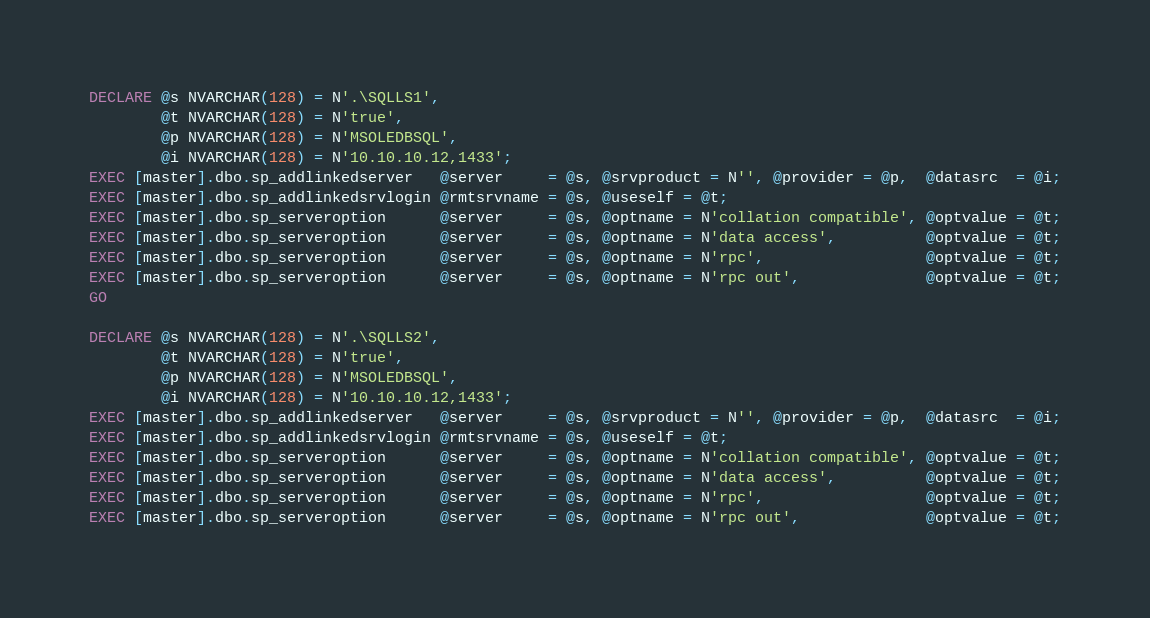<code> <loc_0><loc_0><loc_500><loc_500><_SQL_>DECLARE @s NVARCHAR(128) = N'.\SQLLS1',
        @t NVARCHAR(128) = N'true',
        @p NVARCHAR(128) = N'MSOLEDBSQL',
        @i NVARCHAR(128) = N'10.10.10.12,1433';
EXEC [master].dbo.sp_addlinkedserver   @server     = @s, @srvproduct = N'', @provider = @p,  @datasrc  = @i;
EXEC [master].dbo.sp_addlinkedsrvlogin @rmtsrvname = @s, @useself = @t;
EXEC [master].dbo.sp_serveroption      @server     = @s, @optname = N'collation compatible', @optvalue = @t;
EXEC [master].dbo.sp_serveroption      @server     = @s, @optname = N'data access',          @optvalue = @t;
EXEC [master].dbo.sp_serveroption      @server     = @s, @optname = N'rpc',                  @optvalue = @t;
EXEC [master].dbo.sp_serveroption      @server     = @s, @optname = N'rpc out',              @optvalue = @t;
GO

DECLARE @s NVARCHAR(128) = N'.\SQLLS2',
        @t NVARCHAR(128) = N'true',
        @p NVARCHAR(128) = N'MSOLEDBSQL',
        @i NVARCHAR(128) = N'10.10.10.12,1433';
EXEC [master].dbo.sp_addlinkedserver   @server     = @s, @srvproduct = N'', @provider = @p,  @datasrc  = @i;
EXEC [master].dbo.sp_addlinkedsrvlogin @rmtsrvname = @s, @useself = @t;
EXEC [master].dbo.sp_serveroption      @server     = @s, @optname = N'collation compatible', @optvalue = @t;
EXEC [master].dbo.sp_serveroption      @server     = @s, @optname = N'data access',          @optvalue = @t;
EXEC [master].dbo.sp_serveroption      @server     = @s, @optname = N'rpc',                  @optvalue = @t;
EXEC [master].dbo.sp_serveroption      @server     = @s, @optname = N'rpc out',              @optvalue = @t;
</code> 